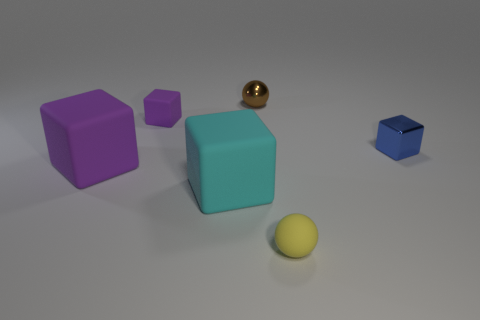The small ball behind the shiny thing on the right side of the tiny metal thing that is left of the tiny yellow rubber sphere is made of what material? Based on the image, the small ball appears to have a reflective surface similar to the shiny object, suggesting it is also made of metal. Metal is known for its reflective properties, often used in objects that require durability and sheen. 